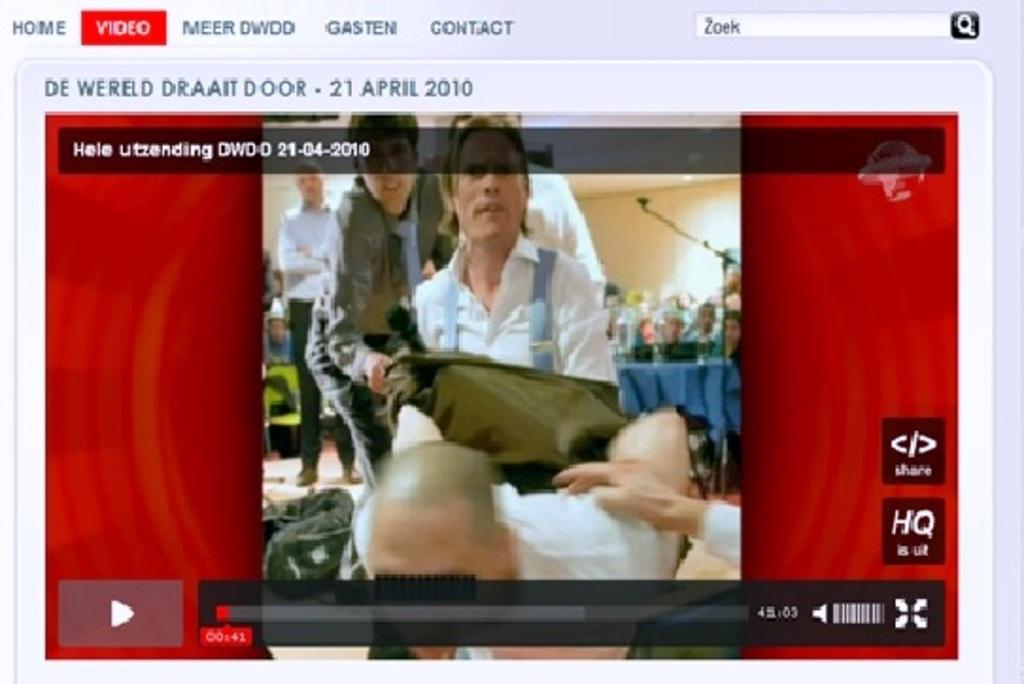What date was this taken on?
Offer a very short reply. 21-04-2010. What time is this video paused at?
Provide a succinct answer. 00:41. 